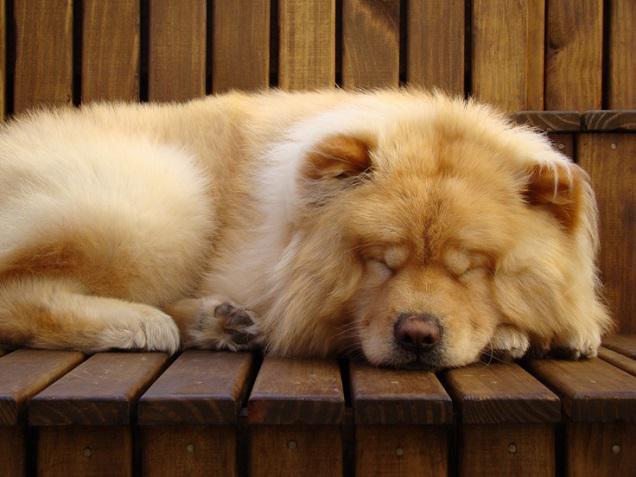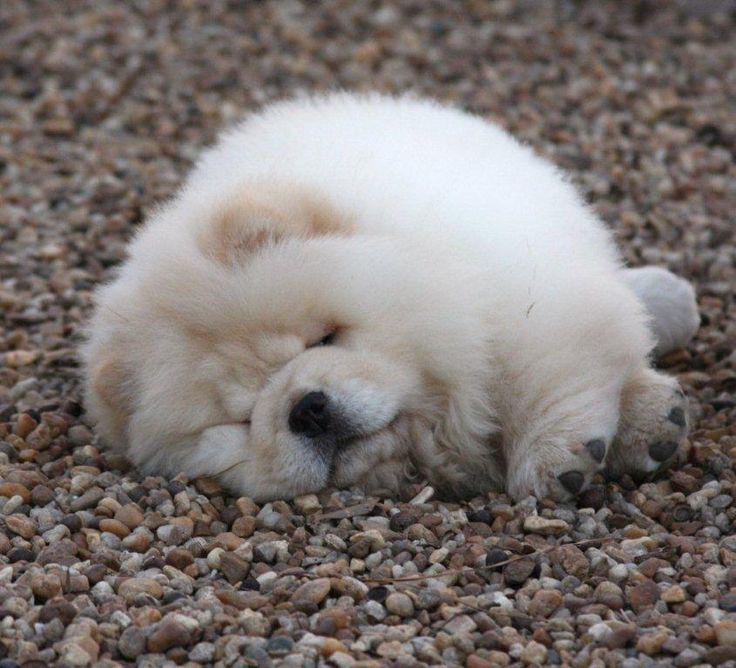The first image is the image on the left, the second image is the image on the right. Analyze the images presented: Is the assertion "The dog in the image on the left is sleeping on the tiled surface." valid? Answer yes or no. No. 